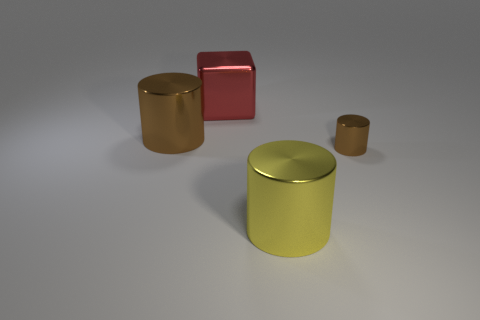Subtract all brown balls. How many brown cylinders are left? 2 Subtract all tiny cylinders. How many cylinders are left? 2 Subtract 1 cylinders. How many cylinders are left? 2 Add 2 blue metal cubes. How many objects exist? 6 Subtract all cylinders. How many objects are left? 1 Subtract all purple blocks. Subtract all small brown shiny cylinders. How many objects are left? 3 Add 3 tiny brown metallic cylinders. How many tiny brown metallic cylinders are left? 4 Add 3 large cyan blocks. How many large cyan blocks exist? 3 Subtract 0 brown balls. How many objects are left? 4 